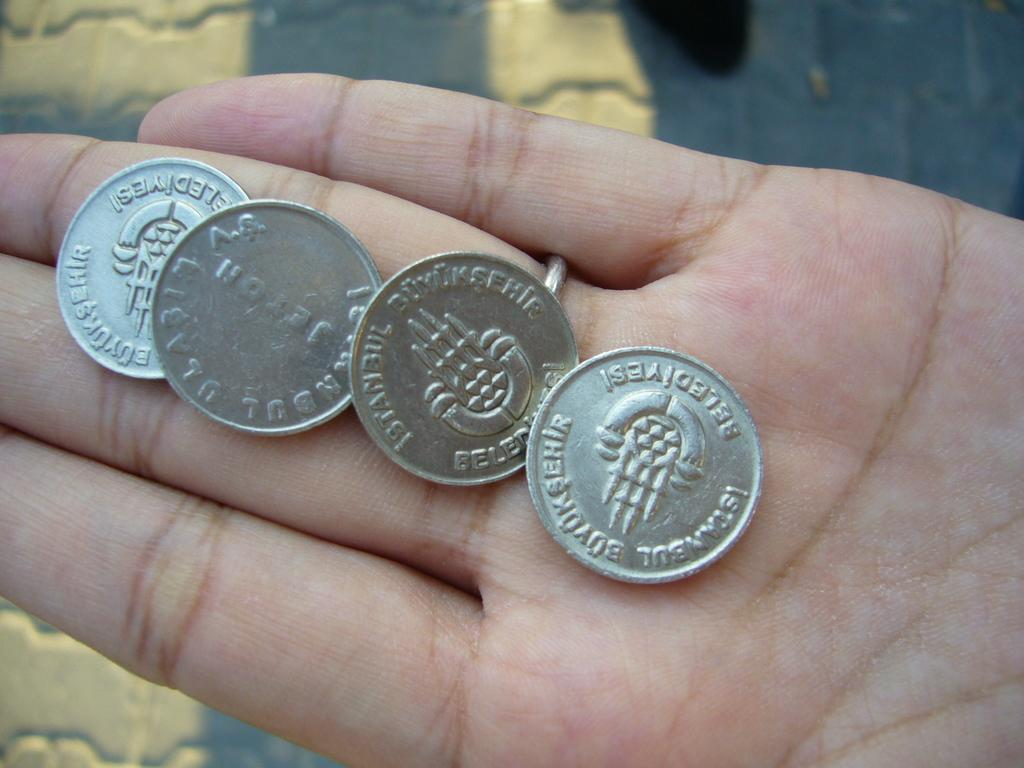How many coins are visible on the person's hand in the image? There are four coins on the person's hand in the image. What can be seen in the background of the image? There are yellow color paintings in the background. What is the surface on which the paintings are placed? The paintings are on a surface, but the specific type of surface is not mentioned in the facts. What arithmetic problem can be solved using the coins in the image? There is no arithmetic problem mentioned or implied in the image, as it only shows four coins on a person's hand. What type of salt is sprinkled on the paintings in the image? There is no salt present in the image; it only features yellow color paintings in the background. 